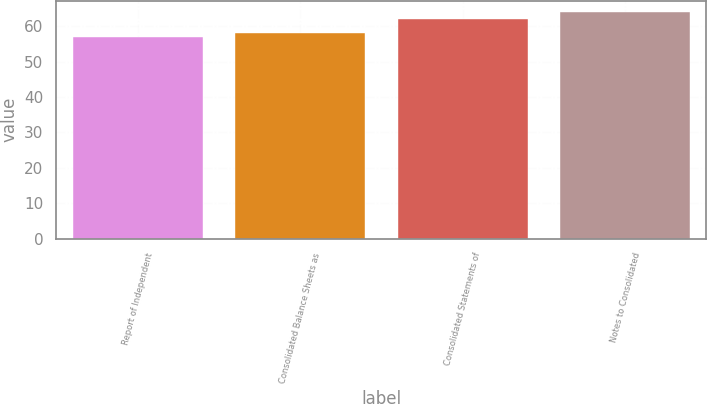<chart> <loc_0><loc_0><loc_500><loc_500><bar_chart><fcel>Report of Independent<fcel>Consolidated Balance Sheets as<fcel>Consolidated Statements of<fcel>Notes to Consolidated<nl><fcel>57<fcel>58<fcel>62<fcel>64<nl></chart> 